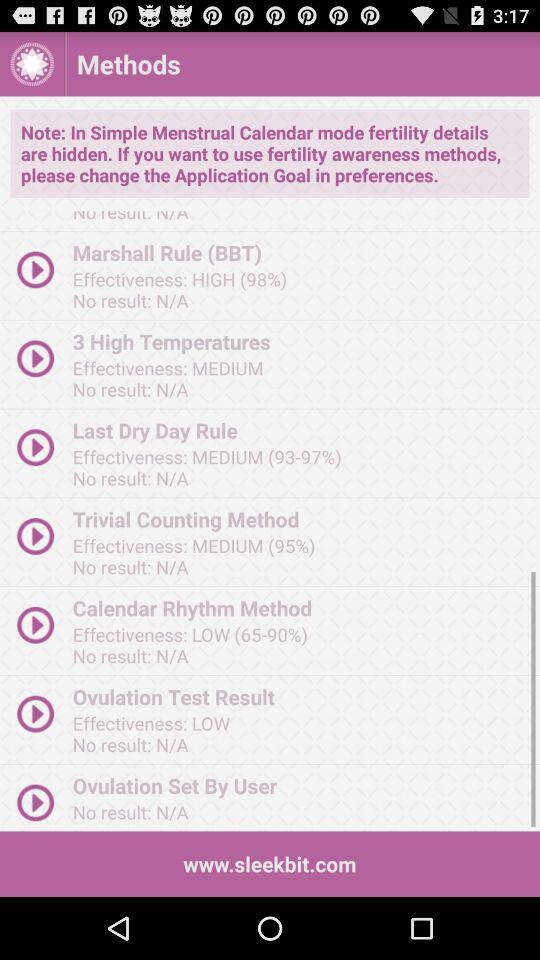What is the effectiveness percentage of the Marshall Rule (BBT)? The effectiveness percentage of the Marshall Rule (BBT) is 98. 